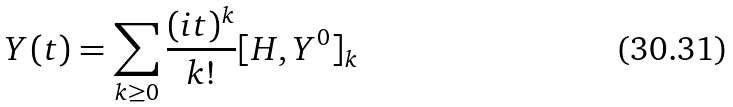<formula> <loc_0><loc_0><loc_500><loc_500>Y ( t ) = \sum _ { k \geq 0 } \frac { ( i t ) ^ { k } } { k ! } [ H , Y ^ { 0 } ] _ { k }</formula> 